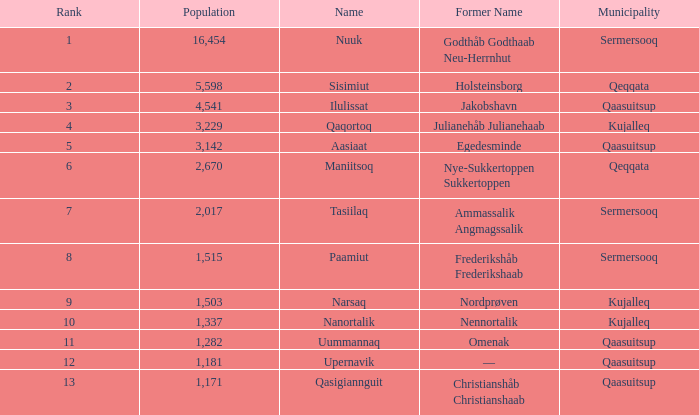What is the population of the 11th rank? 1282.0. 